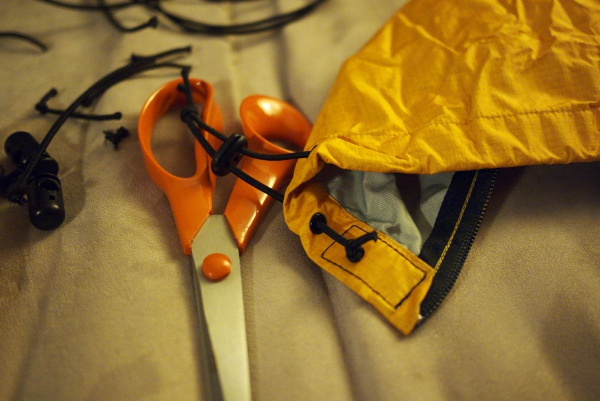Describe the objects in this image and their specific colors. I can see scissors in gray, maroon, red, brown, and black tones in this image. 